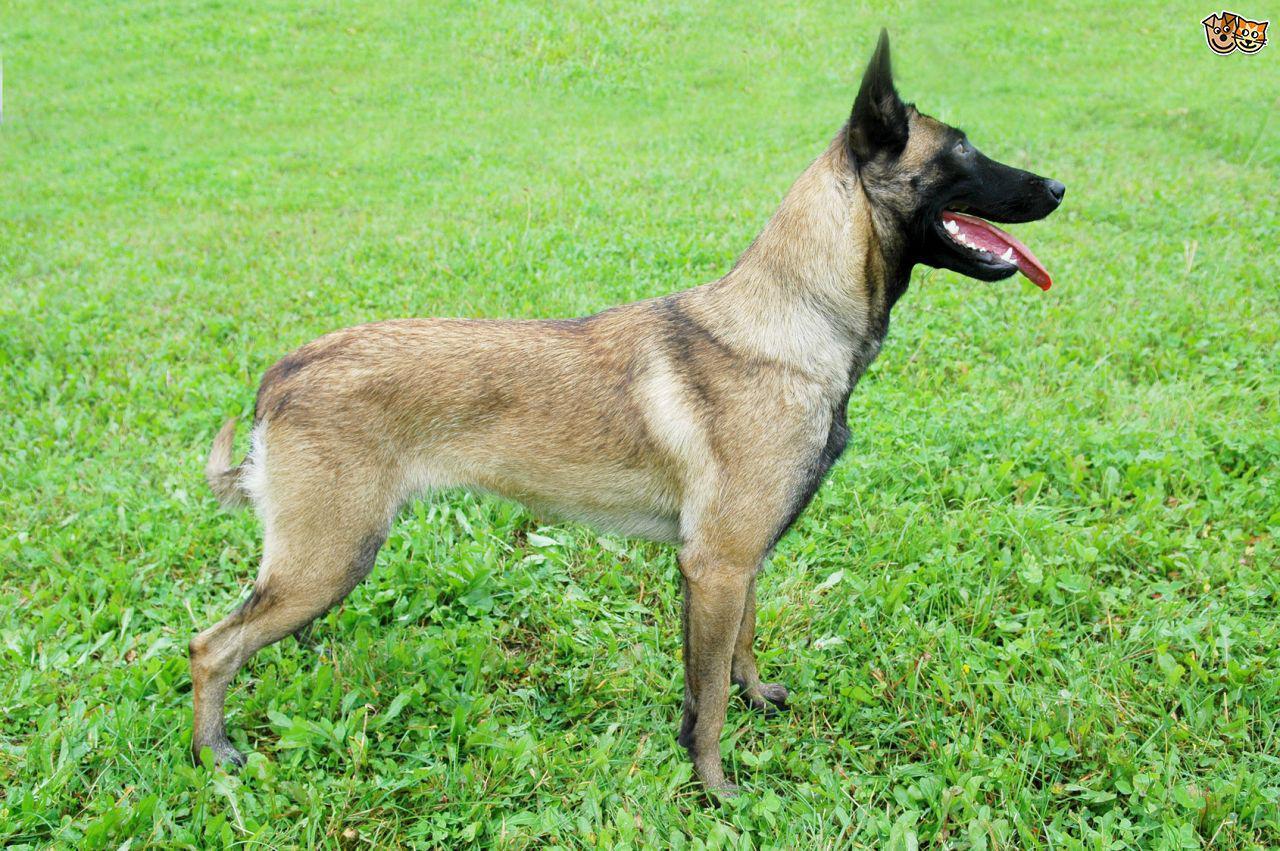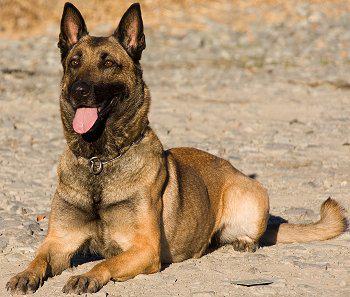The first image is the image on the left, the second image is the image on the right. For the images displayed, is the sentence "One of the dogs is carrying a toy in it's mouth." factually correct? Answer yes or no. No. 